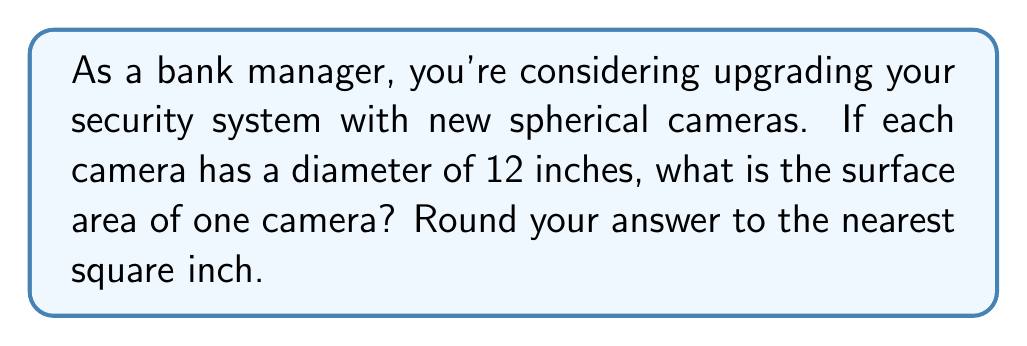What is the answer to this math problem? Let's approach this step-by-step:

1) The formula for the surface area of a sphere is:
   $$A = 4\pi r^2$$
   where $A$ is the surface area and $r$ is the radius of the sphere.

2) We're given the diameter, which is 12 inches. To find the radius, we divide the diameter by 2:
   $$r = \frac{12}{2} = 6\text{ inches}$$

3) Now we can substitute this into our formula:
   $$A = 4\pi (6^2)$$

4) Simplify:
   $$A = 4\pi (36)$$
   $$A = 144\pi$$

5) Calculate (using $\pi \approx 3.14159$):
   $$A \approx 144 * 3.14159 = 452.38896\text{ square inches}$$

6) Rounding to the nearest square inch:
   $$A \approx 452\text{ square inches}$$
Answer: 452 square inches 